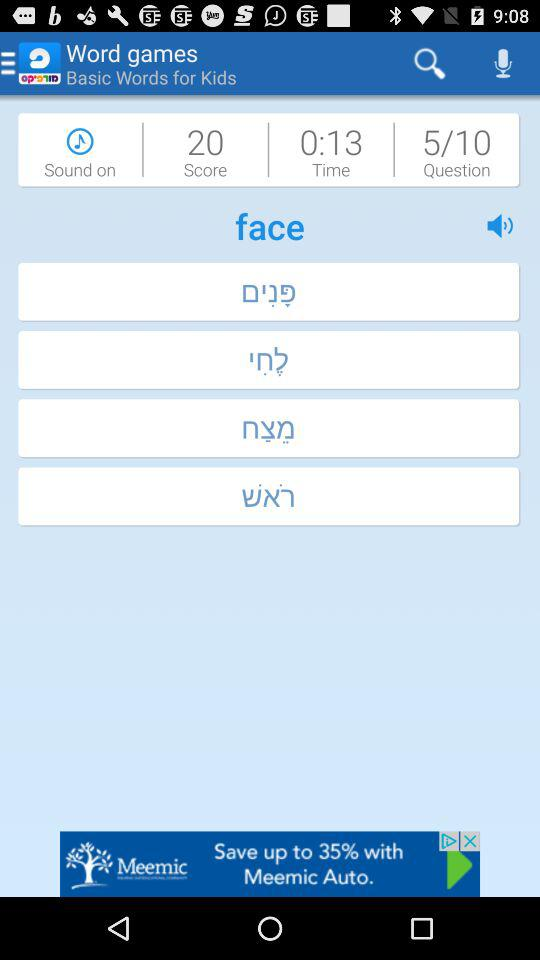How many questions have been answered? There have been 5 questions answered. 